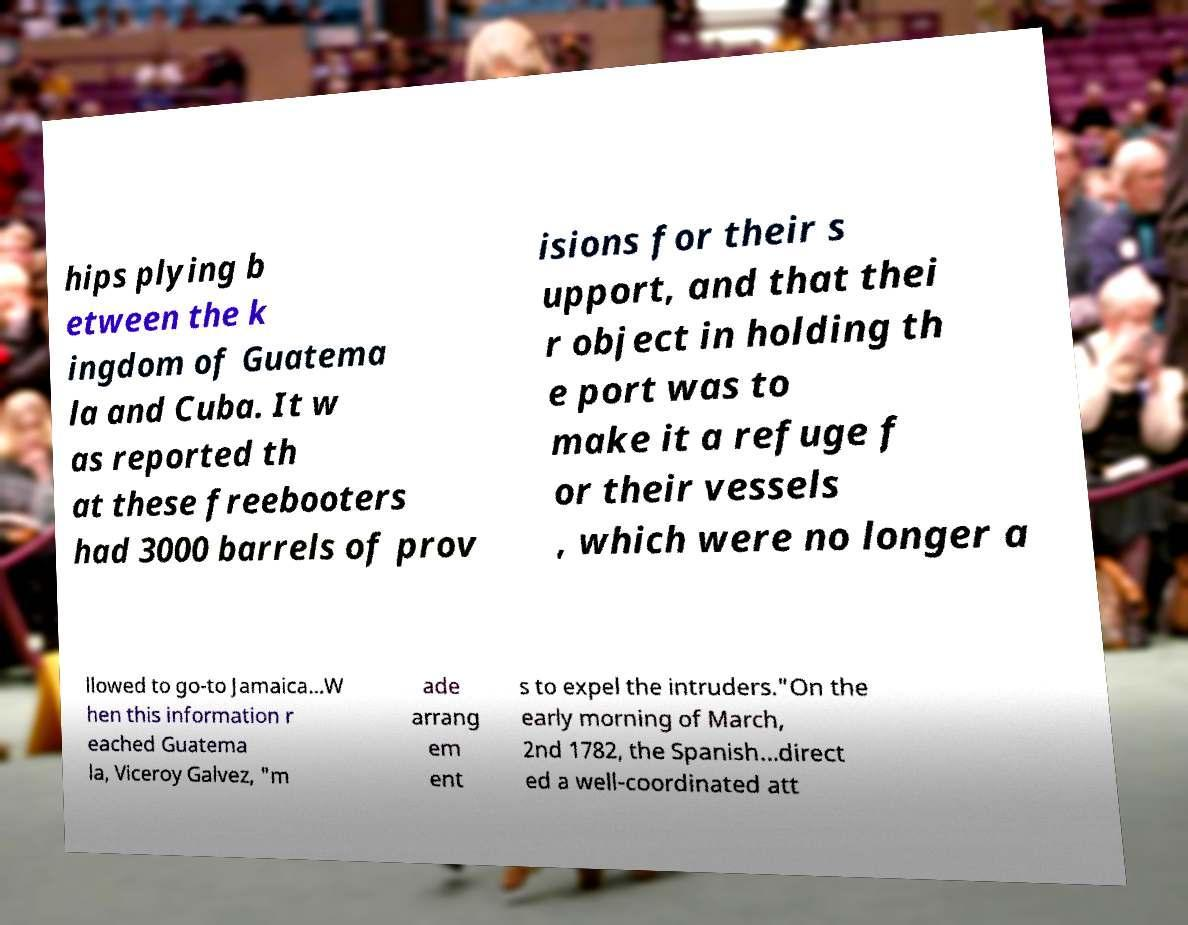Can you read and provide the text displayed in the image?This photo seems to have some interesting text. Can you extract and type it out for me? hips plying b etween the k ingdom of Guatema la and Cuba. It w as reported th at these freebooters had 3000 barrels of prov isions for their s upport, and that thei r object in holding th e port was to make it a refuge f or their vessels , which were no longer a llowed to go-to Jamaica...W hen this information r eached Guatema la, Viceroy Galvez, "m ade arrang em ent s to expel the intruders."On the early morning of March, 2nd 1782, the Spanish...direct ed a well-coordinated att 